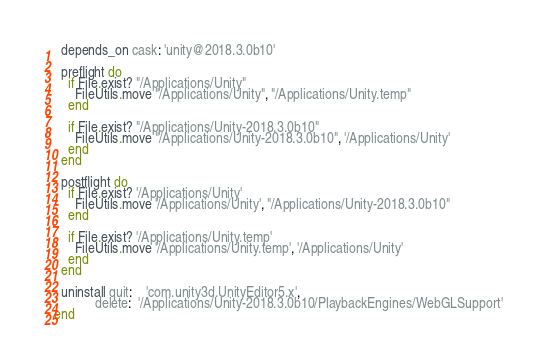Convert code to text. <code><loc_0><loc_0><loc_500><loc_500><_Ruby_>  depends_on cask: 'unity@2018.3.0b10'

  preflight do
    if File.exist? "/Applications/Unity"
      FileUtils.move "/Applications/Unity", "/Applications/Unity.temp"
    end

    if File.exist? "/Applications/Unity-2018.3.0b10"
      FileUtils.move "/Applications/Unity-2018.3.0b10", '/Applications/Unity'
    end
  end

  postflight do
    if File.exist? '/Applications/Unity'
      FileUtils.move '/Applications/Unity', "/Applications/Unity-2018.3.0b10"
    end

    if File.exist? '/Applications/Unity.temp'
      FileUtils.move '/Applications/Unity.temp', '/Applications/Unity'
    end
  end

  uninstall quit:    'com.unity3d.UnityEditor5.x',
            delete:  '/Applications/Unity-2018.3.0b10/PlaybackEngines/WebGLSupport'
end
</code> 